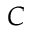Convert formula to latex. <formula><loc_0><loc_0><loc_500><loc_500>C</formula> 